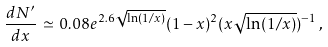<formula> <loc_0><loc_0><loc_500><loc_500>\frac { d N ^ { \prime } } { d x } \, \simeq \, 0 . 0 8 e ^ { 2 . 6 \sqrt { \ln ( 1 / x ) } } ( 1 - x ) ^ { 2 } ( x \sqrt { \ln ( 1 / x ) } ) ^ { - 1 } \, ,</formula> 